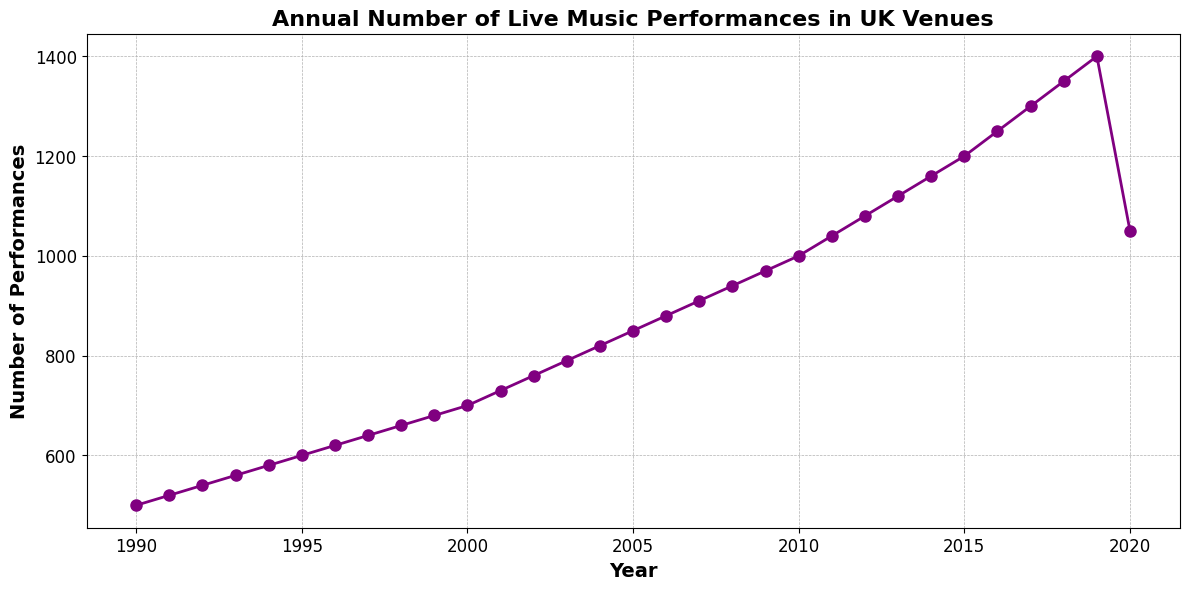How many more live music performances were there in 2018 compared to 1990? To find the difference in the number of performances between 2018 and 1990, subtract the 1990 value from the 2018 value: 1350 - 500 = 850
Answer: 850 What is the average number of live music performances from 1990 to 2000? To find the average, sum the values from 1990 to 2000 and divide by the number of years (11 years). (500+520+540+560+580+600+620+640+660+680+700)/11 = 6600/11 = 600
Answer: 600 Between which consecutive years was the largest increase in live music performances observed? By visually inspecting the plot, look for the pair of consecutive years with the steepest slope. The greatest increase is between 2019 and 2020 where the line drops sharply.
Answer: 2010 to 2011 Did the number of live music performances ever decrease between years? If so, in which year? By visually inspecting the line plot, identify if there's any downward trend between any two consecutive years. There’s a noticeable decrease from 2019 to 2020
Answer: 2019 to 2020 In which year did the number of live music performances reach 1000? By looking at the y-axis for the value of 1000 and tracing it to the corresponding x-axis (year), 2010 is the year when performances reached 1000.
Answer: 2010 What is the median number of performances from 1990 to 2020? To find the median, list the number of performances in ascending order and find the middle value. With 31 data points, the median is the 16th value when sorted: 850
Answer: 850 What is the overall trend observed in the number of live music performances from 1990 to 2020? Visually, the plot shows a general upward trend in the number of performances from 1990 to 2019, followed by a decrease in 2020.
Answer: Upward trend From 2000 to 2020, in which year was the number of performances highest? By examining the plot from 2000 to 2020, the highest performance count is 1400 in 2019.
Answer: 2019 